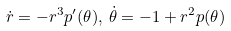<formula> <loc_0><loc_0><loc_500><loc_500>\dot { r } = - r ^ { 3 } p ^ { \prime } ( \theta ) , \, \dot { \theta } = - 1 + r ^ { 2 } p ( \theta )</formula> 